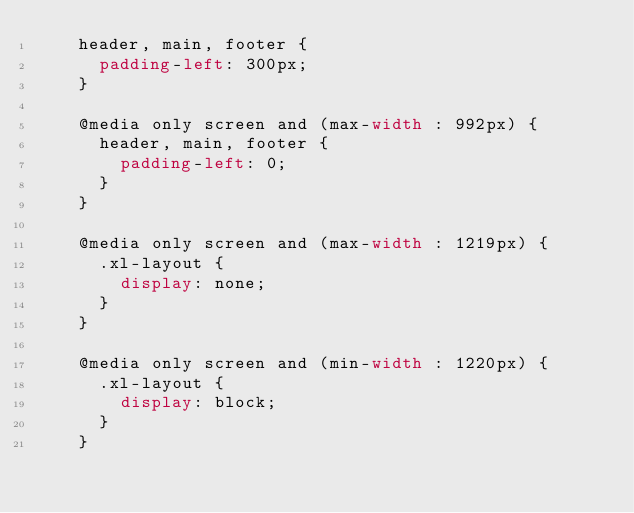<code> <loc_0><loc_0><loc_500><loc_500><_CSS_>    header, main, footer {
      padding-left: 300px;
    }

    @media only screen and (max-width : 992px) {
      header, main, footer {
        padding-left: 0;
      }
    }

    @media only screen and (max-width : 1219px) {
      .xl-layout {
        display: none;
      }
    }

    @media only screen and (min-width : 1220px) {
      .xl-layout {
        display: block;
      }
    }
</code> 